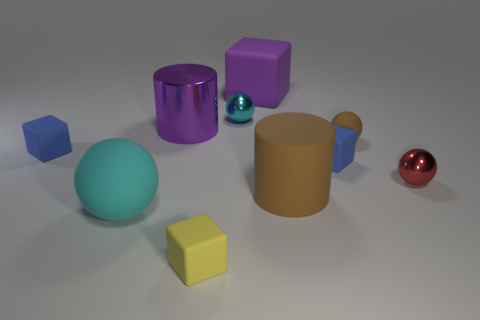Subtract all large purple cubes. How many cubes are left? 3 Subtract all brown balls. How many balls are left? 3 Subtract all blocks. How many objects are left? 6 Subtract 3 balls. How many balls are left? 1 Subtract all purple cubes. How many purple balls are left? 0 Subtract all large purple matte objects. Subtract all big purple matte things. How many objects are left? 8 Add 4 tiny red metallic balls. How many tiny red metallic balls are left? 5 Add 8 big purple things. How many big purple things exist? 10 Subtract 1 brown cylinders. How many objects are left? 9 Subtract all gray cubes. Subtract all brown balls. How many cubes are left? 4 